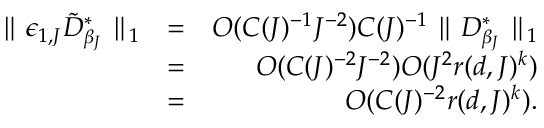Convert formula to latex. <formula><loc_0><loc_0><loc_500><loc_500>\begin{array} { r l r } { \| \epsilon _ { 1 , J } \tilde { D } _ { \beta _ { J } } ^ { * } \| _ { 1 } } & { = } & { O ( C ( J ) ^ { - 1 } J ^ { - 2 } ) C ( J ) ^ { - 1 } \| D _ { \beta _ { J } } ^ { * } \| _ { 1 } } \\ & { = } & { O ( C ( J ) ^ { - 2 } J ^ { - 2 } ) O ( J ^ { 2 } r ( d , J ) ^ { k } ) } \\ & { = } & { O ( C ( J ) ^ { - 2 } r ( d , J ) ^ { k } ) . } \end{array}</formula> 